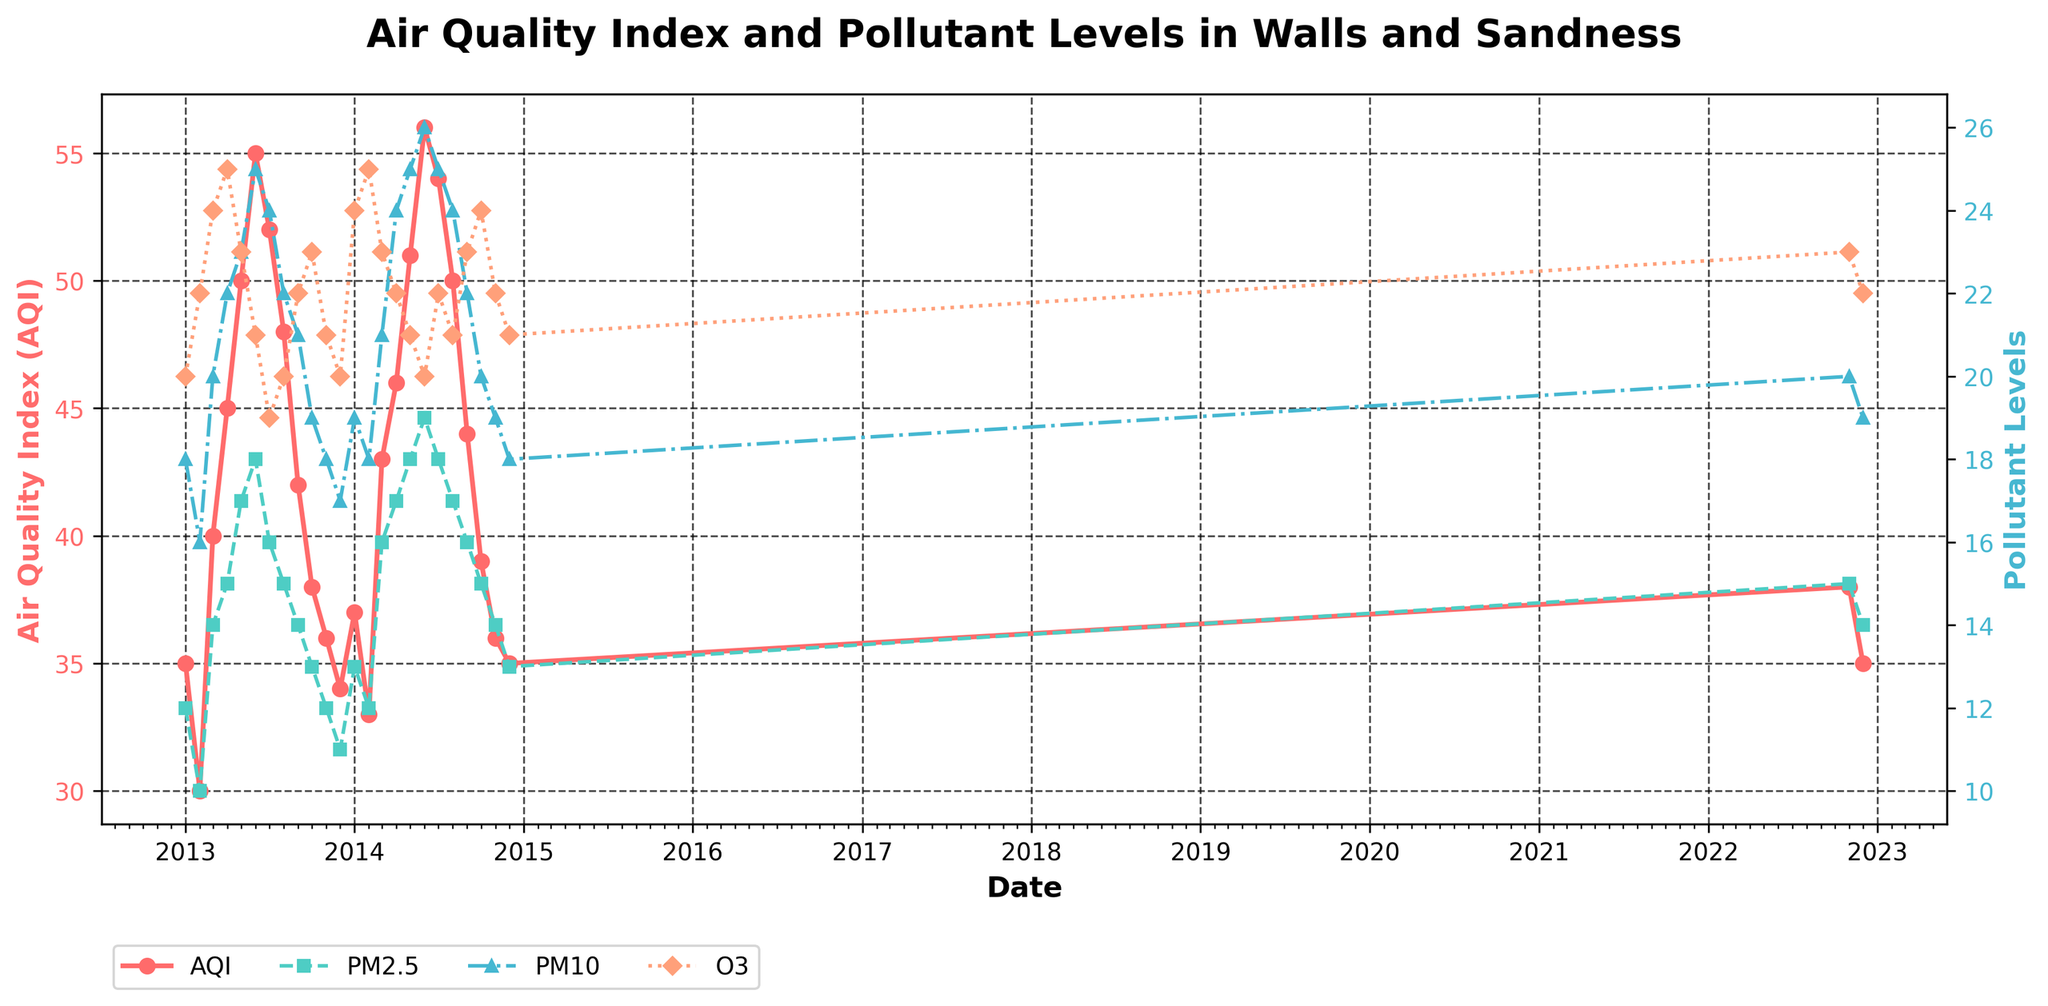What is the title of the plot? The title is displayed at the top of the plot. It reads "Air Quality Index and Pollutant Levels in Walls and Sandness."
Answer: Air Quality Index and Pollutant Levels in Walls and Sandness What does the red line in the plot represent? The red line represents the Air Quality Index (AQI). It is specified in the legend and also labeled with red text on the y-axis.
Answer: Air Quality Index (AQI) How many times does the AQI exceed 50? By observing the plot, we see that the AQI exceeds 50 in June 2013, June 2014, and July 2014. Counting these instances gives us a total of 3.
Answer: 3 During which months in 2014 did PM2.5 reach its maximum value? According to the plot, PM2.5 reaches its maximum value of 19 in June 2014.
Answer: June 2014 What was the AQI value in December 2014? By locating December 2014 on the x-axis and tracing it to the AQI line, we find the value is 35.
Answer: 35 How does the PM10 level in March 2013 compare with November 2014? By checking the plot, PM10 in March 2013 is 20, and in November 2014, it is 19. Therefore, PM10 in March 2013 is higher.
Answer: March 2013 Which pollutant shows the most distinct seasonal trend and what is a key observation from that trend? Observing the trends of all pollutants, PM2.5 shows a notable seasonal trend where it peaks during the summer months. For example, PM2.5 is highest in June 2013 and June 2014.
Answer: PM2.5, with peaks in summer What is the average AQI in the year 2013 from the data provided? Sum of AQI values in 2013: (35 + 30 + 40 + 45 + 50 + 55 + 52 + 48 + 42 + 38 + 36 + 34) = 505. Number of months: 12. Average AQI = 505 / 12 = 42.08
Answer: 42.08 Compare the AQI trends for the years 2013 and 2014. Which year had generally better air quality? Comparing the AQI lines for both years, 2013 generally has higher AQI values compared to 2014, indicating that 2014 had better air quality overall.
Answer: 2014 What can you infer about the relationship between AQI and O3 levels from the plot? Both AQI and O3 show similar trends with peaks in specific months, implying a positive correlation between AQI and O3 levels. When O3 increases, AQI tends to increase as well.
Answer: Positive correlation 